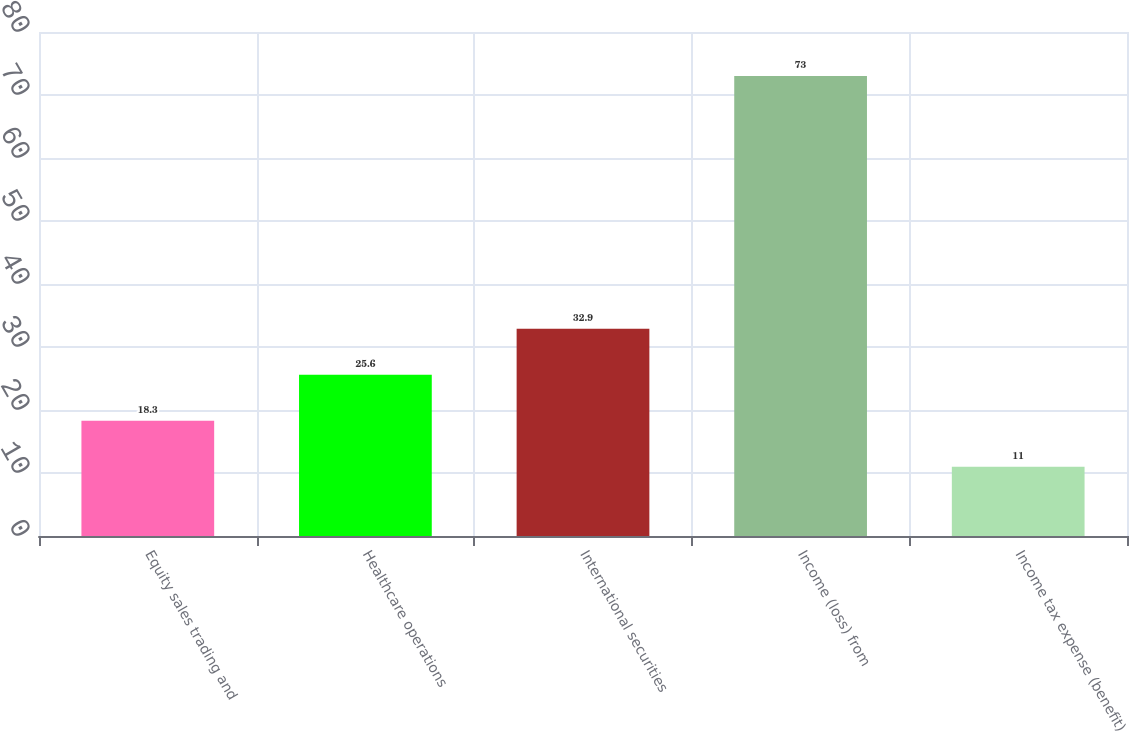<chart> <loc_0><loc_0><loc_500><loc_500><bar_chart><fcel>Equity sales trading and<fcel>Healthcare operations<fcel>International securities<fcel>Income (loss) from<fcel>Income tax expense (benefit)<nl><fcel>18.3<fcel>25.6<fcel>32.9<fcel>73<fcel>11<nl></chart> 